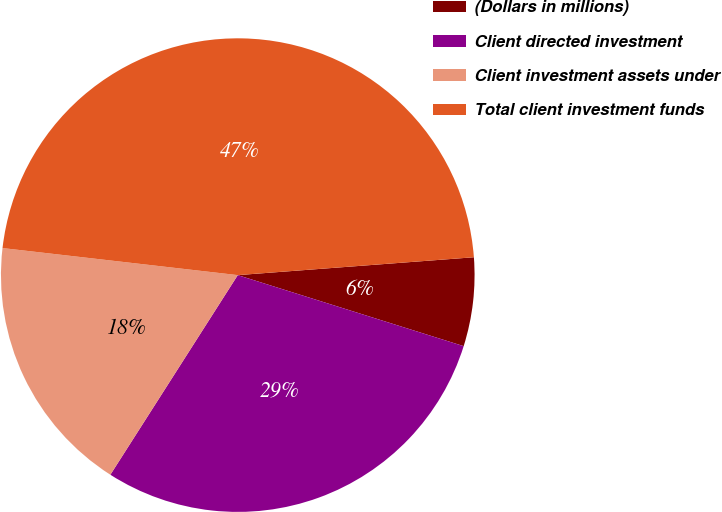Convert chart. <chart><loc_0><loc_0><loc_500><loc_500><pie_chart><fcel>(Dollars in millions)<fcel>Client directed investment<fcel>Client investment assets under<fcel>Total client investment funds<nl><fcel>6.05%<fcel>29.19%<fcel>17.78%<fcel>46.97%<nl></chart> 